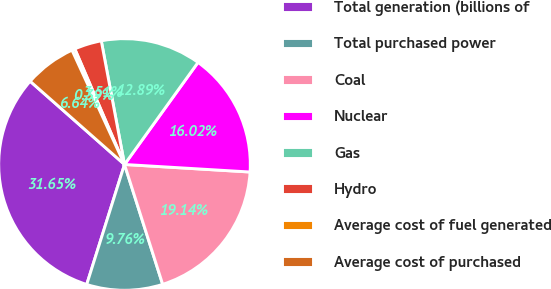<chart> <loc_0><loc_0><loc_500><loc_500><pie_chart><fcel>Total generation (billions of<fcel>Total purchased power<fcel>Coal<fcel>Nuclear<fcel>Gas<fcel>Hydro<fcel>Average cost of fuel generated<fcel>Average cost of purchased<nl><fcel>31.65%<fcel>9.76%<fcel>19.14%<fcel>16.02%<fcel>12.89%<fcel>3.51%<fcel>0.39%<fcel>6.64%<nl></chart> 